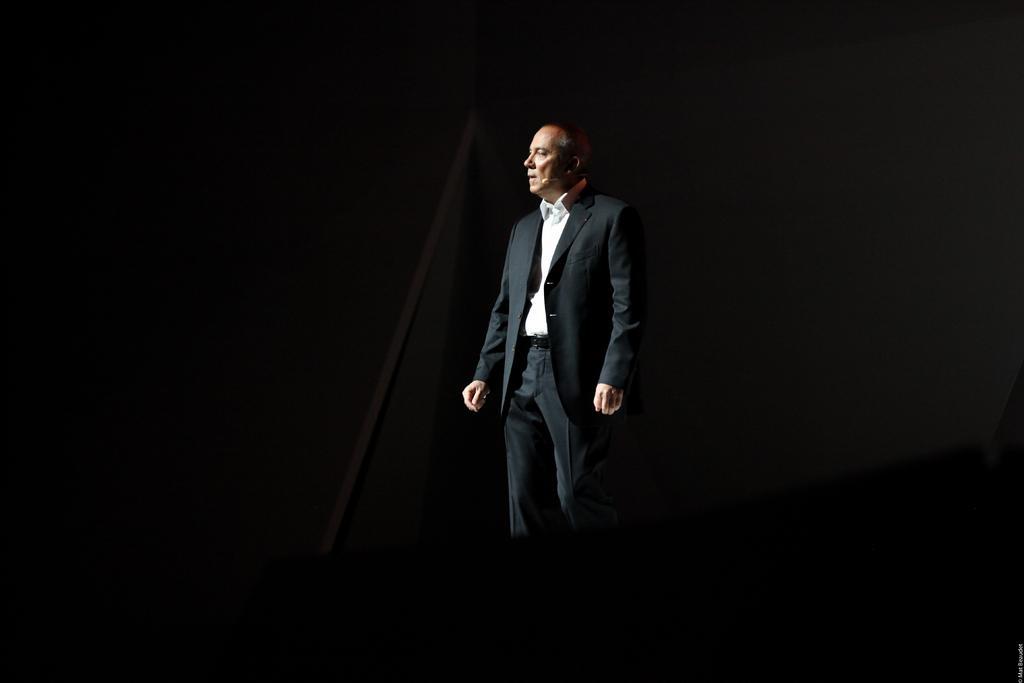Could you give a brief overview of what you see in this image? As we can see in the image there is a man wearing black color jacket and the image is little dark. 